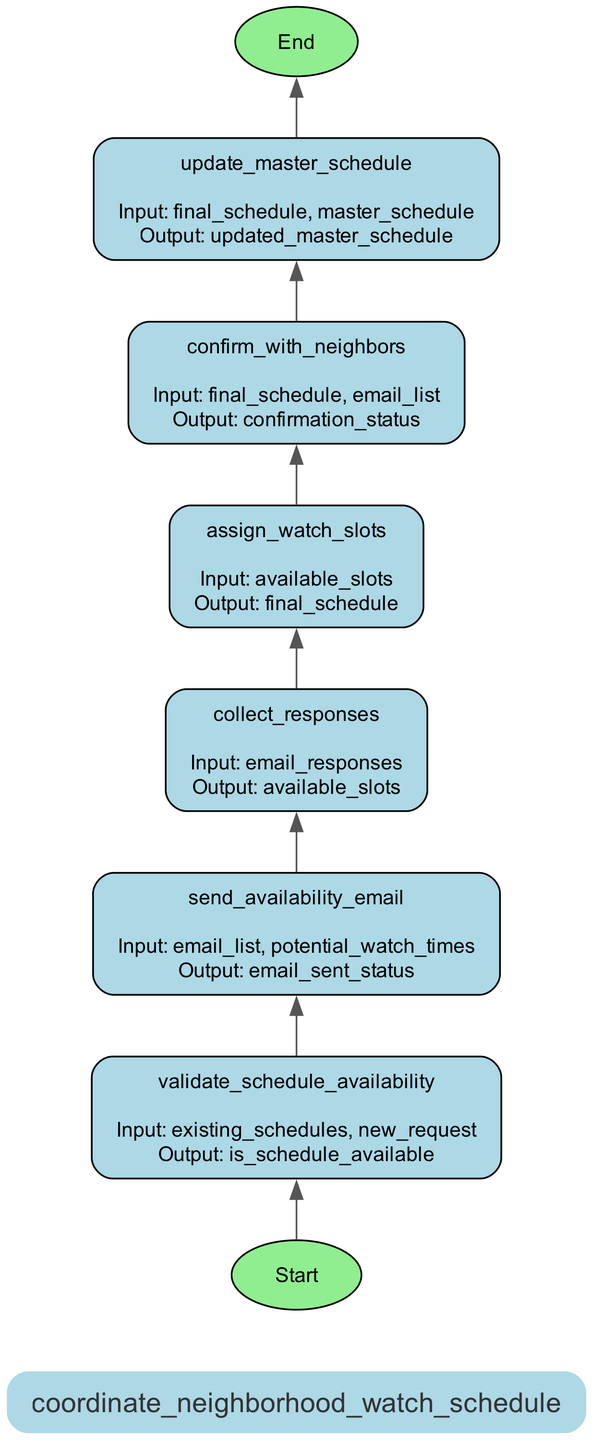what is the first step in this process? The first step is determined by looking at the flowchart's starting point, which leads to the first node, labeled "validate_schedule_availability". Therefore, the first action in this sequence is to validate the schedule availability.
Answer: validate_schedule_availability how many steps are there in the diagram? Counting the number of distinct steps listed in the diagram reveals there are six steps included in the process of coordinating the neighborhood watch schedule.
Answer: six what is the output of "assign_watch_slots"? Referring to the specific node in the diagram labeled "assign_watch_slots", the output indicated is "final_schedule". Hence, this is the result produced once this step is complete.
Answer: final_schedule which step comes before "confirm_with_neighbors"? By examining the flow of the diagram, we see that the step immediately preceding "confirm_with_neighbors" is "assign_watch_slots", as they are connected in sequence.
Answer: assign_watch_slots how is the master schedule updated? The flowchart indicates that the "update_master_schedule" step utilizes the final schedule and the master schedule as inputs, and its output is the "updated_master_schedule". This denotes the process by which the master schedule is revised.
Answer: updated_master_schedule what is the input for the "send_availability_email" step? The input required for the "send_availability_email" step, as detailed in the diagram, is composed of the "email_list" and "potential_watch_times". These elements are crucial for sending out notification emails to neighbors.
Answer: email_list, potential_watch_times what is the last step of the process? The last step in this flowchart is represented by the node leading to the endpoint, which is labeled "end_coordinating_schedule". This signifies the conclusion of the entire scheduling coordination process.
Answer: end_coordinating_schedule what kind of email is sent in the "send_availability_email" step? The description associated with the "send_availability_email" step illustrates that it is designed to notify neighbors about potential watch times via email. This refers specifically to the notification of watch times.
Answer: notify neighbors about potential watch times 